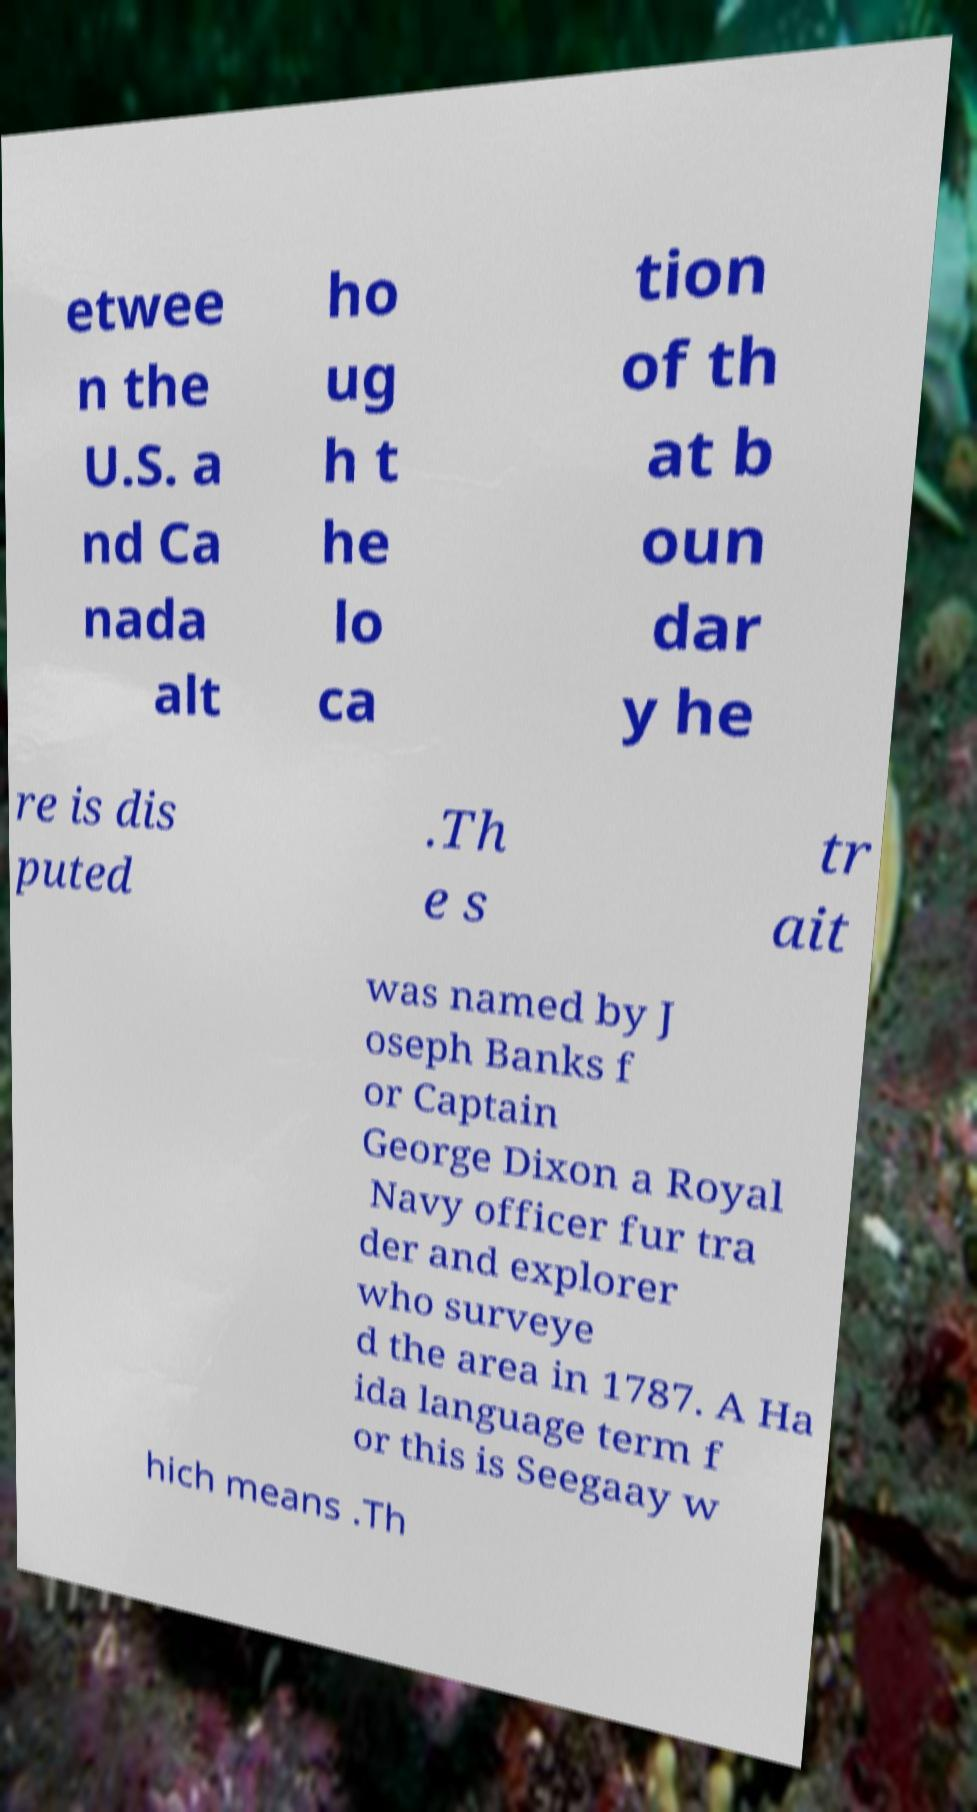I need the written content from this picture converted into text. Can you do that? etwee n the U.S. a nd Ca nada alt ho ug h t he lo ca tion of th at b oun dar y he re is dis puted .Th e s tr ait was named by J oseph Banks f or Captain George Dixon a Royal Navy officer fur tra der and explorer who surveye d the area in 1787. A Ha ida language term f or this is Seegaay w hich means .Th 